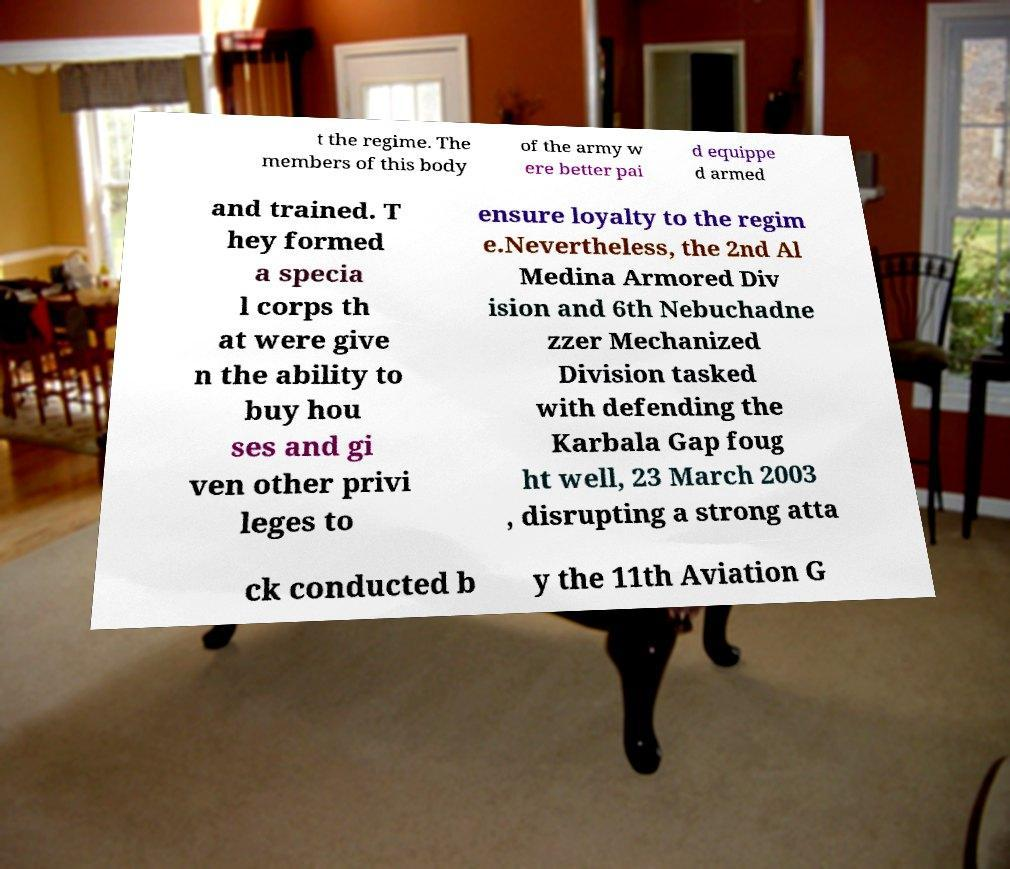Please read and relay the text visible in this image. What does it say? t the regime. The members of this body of the army w ere better pai d equippe d armed and trained. T hey formed a specia l corps th at were give n the ability to buy hou ses and gi ven other privi leges to ensure loyalty to the regim e.Nevertheless, the 2nd Al Medina Armored Div ision and 6th Nebuchadne zzer Mechanized Division tasked with defending the Karbala Gap foug ht well, 23 March 2003 , disrupting a strong atta ck conducted b y the 11th Aviation G 